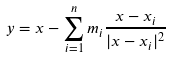<formula> <loc_0><loc_0><loc_500><loc_500>y = x - \sum ^ { n } _ { i = 1 } m _ { i } \frac { x - x _ { i } } { | x - x _ { i } | ^ { 2 } }</formula> 